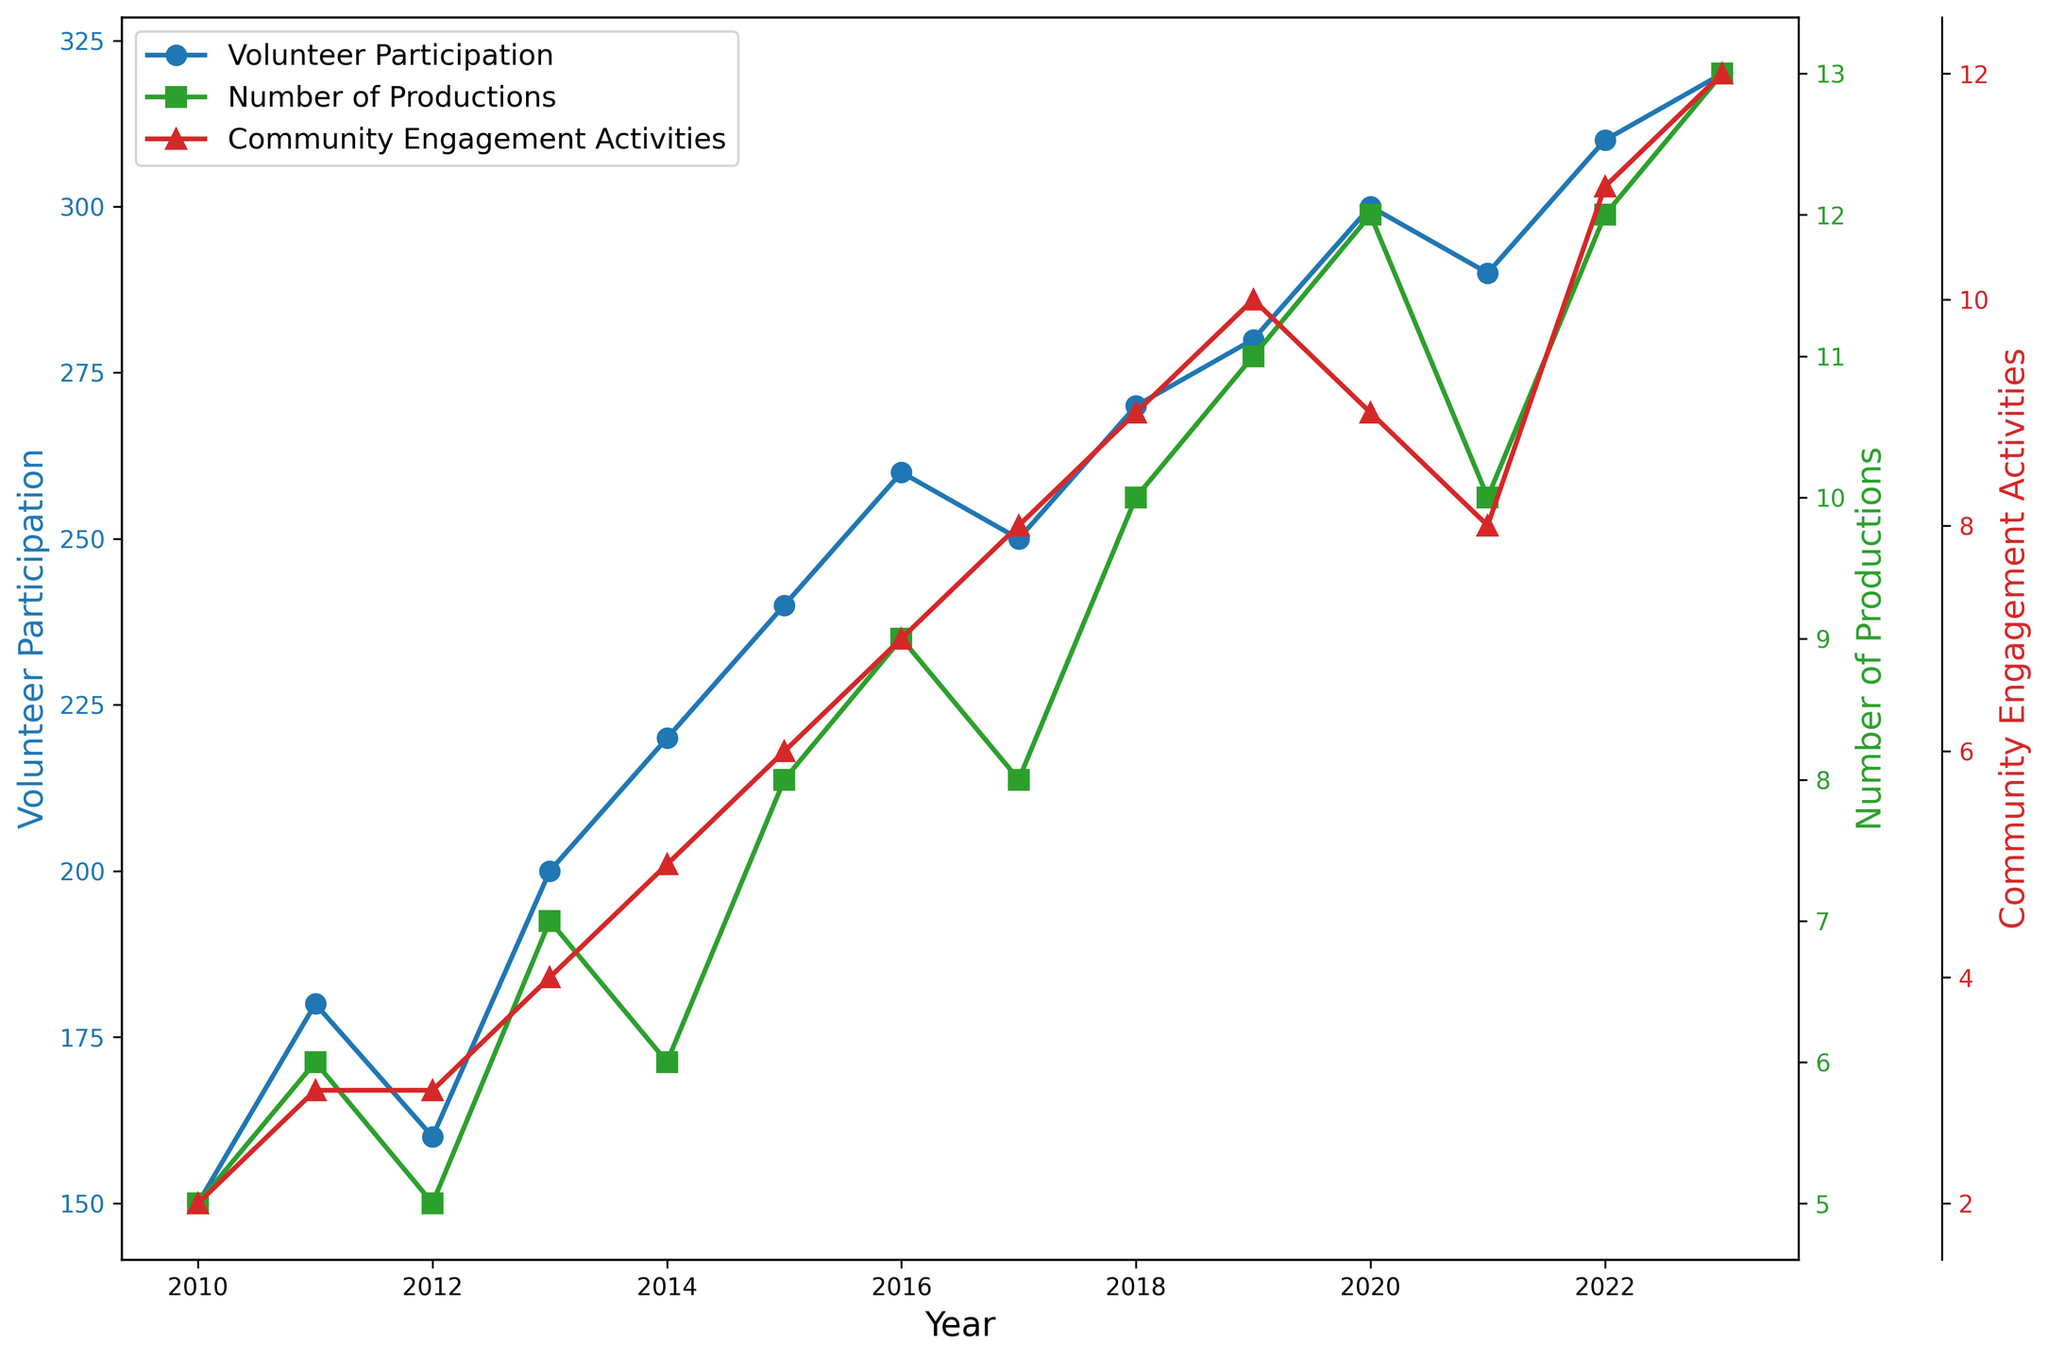How has volunteer participation trended over the years from 2010 to 2023? Volunteer participation has generally increased from 150 in 2010 to 320 in 2023. There are slight fluctuations, but the overall trend is upward.
Answer: Increased Is there any consistent relationship between the number of productions and volunteer participation? Both the number of productions and volunteer participation show an overall upward trend. As the number of productions increases nearly every year, volunteer participation also appears to rise, indicating a positive correlation.
Answer: Positive correlation In which year did community engagement activities see the largest increase compared to the previous year? The largest increase in community engagement activities occurs from 2022 to 2023, where activities increased from 11 to 12.
Answer: 2023 What is the average number of community engagement activities from 2010 to 2023? Sum the community engagement activities for all the years: 2 + 3 + 3 + 4 + 5 + 6 + 7 + 8 + 9 + 10 + 9 + 8 + 11 + 12 = 97. There are 14 years in total, so the average is 97/14 ≈ 6.93.
Answer: 6.93 Which year had the highest volunteer participation and what was the number? The highest volunteer participation occurred in 2023 with a total of 320 volunteers.
Answer: 2023, 320 How do changes in community engagement activities relate to changes in the number of productions over the years? Both community engagement activities and the number of productions show a generally increasing trend. Especially from 2012 onward, increases in community engagement activities coincide with increases in the number of productions, suggesting a positive correlation.
Answer: Positive correlation Between 2020 and 2021, did the number of productions increase or decrease, and by how much? The number of productions decreased by 2, from 12 in 2020 to 10 in 2021.
Answer: Decreased by 2 Which year had the lowest number of productions and what was the count? The lowest number of productions occurred in 2010 and 2012, both with 5 productions.
Answer: 2010 and 2012, 5 What is the difference in volunteer participation between 2013 and 2018? In 2013, volunteer participation was 200, while in 2018, it was 270. The difference is 270 - 200 = 70.
Answer: 70 In which year(s) did volunteer participation remain constant without increasing or decreasing? Volunteer participation remained constant between the years 2017 and 2018 at 270.
Answer: 2017 and 2018 